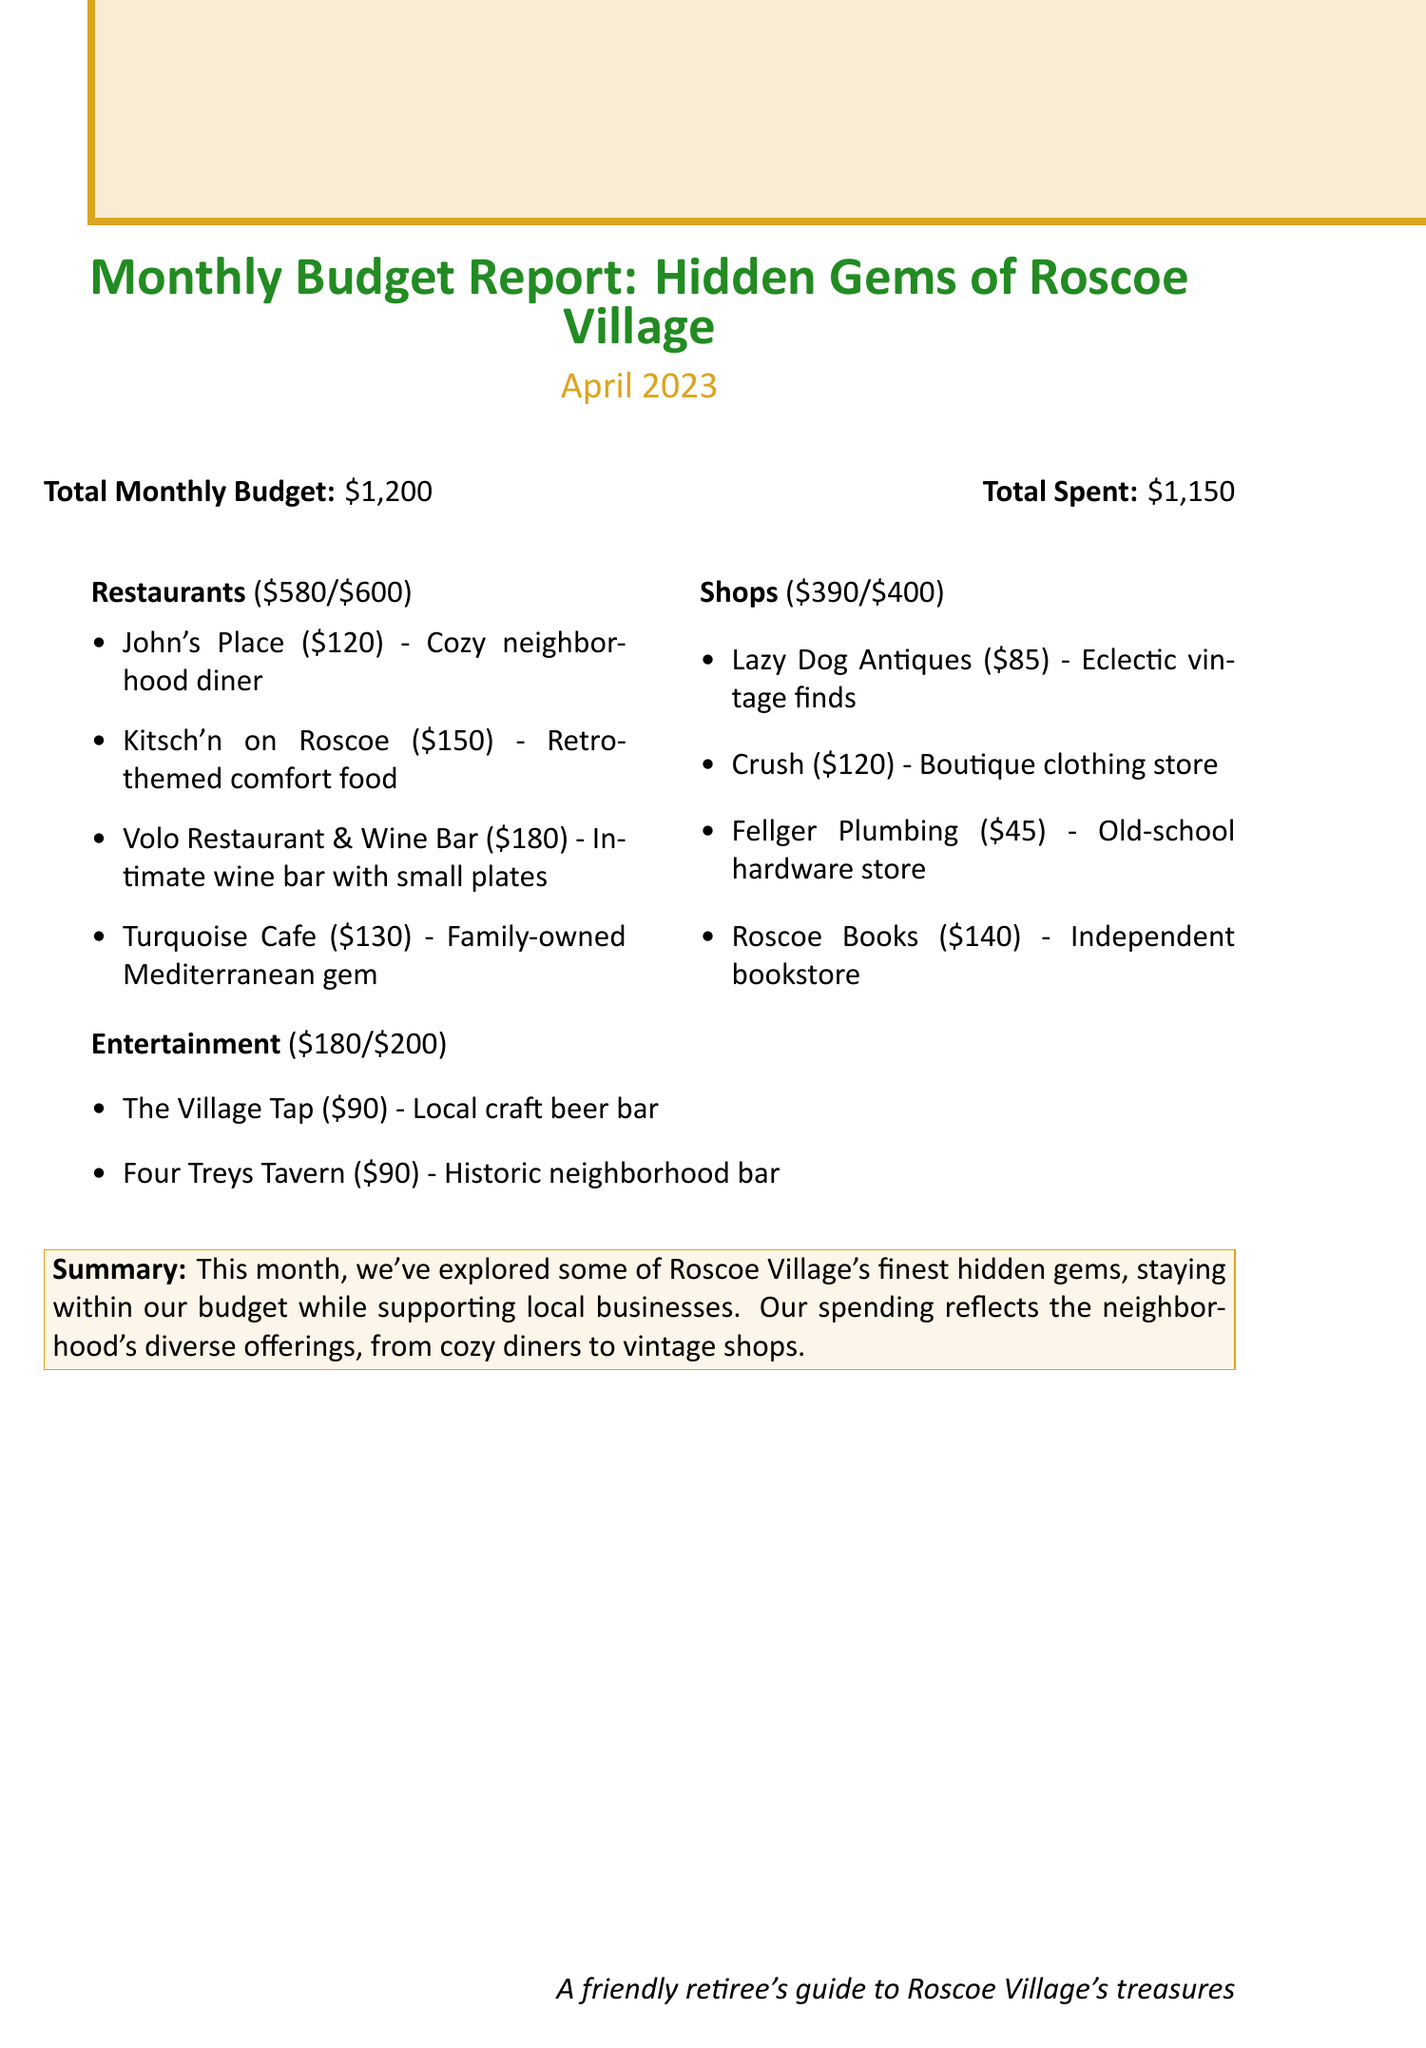What is the total monthly budget? The total monthly budget is stated at the beginning of the document, which is $1200.
Answer: $1200 How much was spent on restaurants? The amount spent on restaurants is listed in the expenditures section, which shows $580.
Answer: $580 What is the description of Turquoise Cafe? The description of Turquoise Cafe is included with its spendings, which is "Family-owned Mediterranean gem."
Answer: Family-owned Mediterranean gem Which shop had the highest expenditure? By comparing the expenditures of shops listed, the shop with the highest spending is identified, which is Roscoe Books at $140.
Answer: Roscoe Books What is the total spent across all categories? The total spent across all categories is mentioned in the report as $1150.
Answer: $1150 How much budget was allocated for entertainment? The budget allocation for entertainment is detailed in the document, which amounts to $200.
Answer: $200 What percentage of the restaurant budget was spent? This requires calculating the percentage based on the spent and the budget, which is 580/600 * 100 = 96.67%.
Answer: 96.67% What is the summary of this month's spending? The summary section provides an overview of the month's spending activities, focusing on supporting local businesses.
Answer: Supporting local businesses How much was spent on Lazy Dog Antiques? The document specifies the expenditure for Lazy Dog Antiques as $85.
Answer: $85 